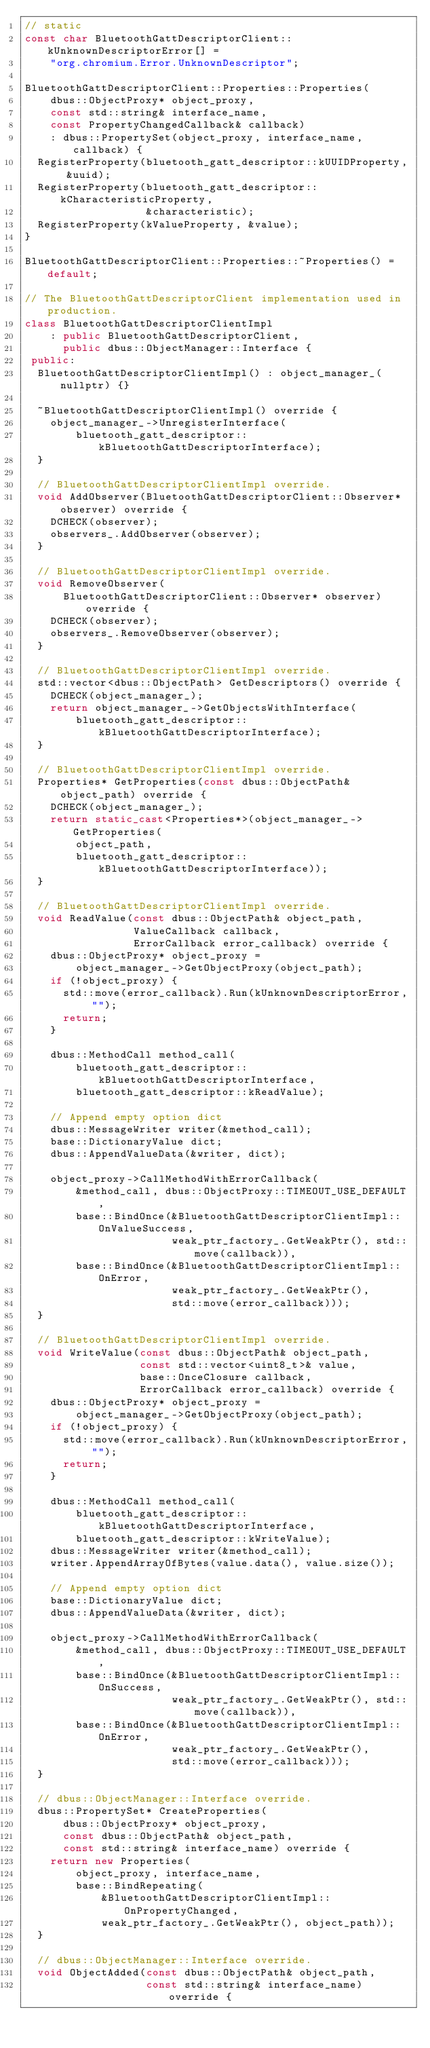<code> <loc_0><loc_0><loc_500><loc_500><_C++_>// static
const char BluetoothGattDescriptorClient::kUnknownDescriptorError[] =
    "org.chromium.Error.UnknownDescriptor";

BluetoothGattDescriptorClient::Properties::Properties(
    dbus::ObjectProxy* object_proxy,
    const std::string& interface_name,
    const PropertyChangedCallback& callback)
    : dbus::PropertySet(object_proxy, interface_name, callback) {
  RegisterProperty(bluetooth_gatt_descriptor::kUUIDProperty, &uuid);
  RegisterProperty(bluetooth_gatt_descriptor::kCharacteristicProperty,
                   &characteristic);
  RegisterProperty(kValueProperty, &value);
}

BluetoothGattDescriptorClient::Properties::~Properties() = default;

// The BluetoothGattDescriptorClient implementation used in production.
class BluetoothGattDescriptorClientImpl
    : public BluetoothGattDescriptorClient,
      public dbus::ObjectManager::Interface {
 public:
  BluetoothGattDescriptorClientImpl() : object_manager_(nullptr) {}

  ~BluetoothGattDescriptorClientImpl() override {
    object_manager_->UnregisterInterface(
        bluetooth_gatt_descriptor::kBluetoothGattDescriptorInterface);
  }

  // BluetoothGattDescriptorClientImpl override.
  void AddObserver(BluetoothGattDescriptorClient::Observer* observer) override {
    DCHECK(observer);
    observers_.AddObserver(observer);
  }

  // BluetoothGattDescriptorClientImpl override.
  void RemoveObserver(
      BluetoothGattDescriptorClient::Observer* observer) override {
    DCHECK(observer);
    observers_.RemoveObserver(observer);
  }

  // BluetoothGattDescriptorClientImpl override.
  std::vector<dbus::ObjectPath> GetDescriptors() override {
    DCHECK(object_manager_);
    return object_manager_->GetObjectsWithInterface(
        bluetooth_gatt_descriptor::kBluetoothGattDescriptorInterface);
  }

  // BluetoothGattDescriptorClientImpl override.
  Properties* GetProperties(const dbus::ObjectPath& object_path) override {
    DCHECK(object_manager_);
    return static_cast<Properties*>(object_manager_->GetProperties(
        object_path,
        bluetooth_gatt_descriptor::kBluetoothGattDescriptorInterface));
  }

  // BluetoothGattDescriptorClientImpl override.
  void ReadValue(const dbus::ObjectPath& object_path,
                 ValueCallback callback,
                 ErrorCallback error_callback) override {
    dbus::ObjectProxy* object_proxy =
        object_manager_->GetObjectProxy(object_path);
    if (!object_proxy) {
      std::move(error_callback).Run(kUnknownDescriptorError, "");
      return;
    }

    dbus::MethodCall method_call(
        bluetooth_gatt_descriptor::kBluetoothGattDescriptorInterface,
        bluetooth_gatt_descriptor::kReadValue);

    // Append empty option dict
    dbus::MessageWriter writer(&method_call);
    base::DictionaryValue dict;
    dbus::AppendValueData(&writer, dict);

    object_proxy->CallMethodWithErrorCallback(
        &method_call, dbus::ObjectProxy::TIMEOUT_USE_DEFAULT,
        base::BindOnce(&BluetoothGattDescriptorClientImpl::OnValueSuccess,
                       weak_ptr_factory_.GetWeakPtr(), std::move(callback)),
        base::BindOnce(&BluetoothGattDescriptorClientImpl::OnError,
                       weak_ptr_factory_.GetWeakPtr(),
                       std::move(error_callback)));
  }

  // BluetoothGattDescriptorClientImpl override.
  void WriteValue(const dbus::ObjectPath& object_path,
                  const std::vector<uint8_t>& value,
                  base::OnceClosure callback,
                  ErrorCallback error_callback) override {
    dbus::ObjectProxy* object_proxy =
        object_manager_->GetObjectProxy(object_path);
    if (!object_proxy) {
      std::move(error_callback).Run(kUnknownDescriptorError, "");
      return;
    }

    dbus::MethodCall method_call(
        bluetooth_gatt_descriptor::kBluetoothGattDescriptorInterface,
        bluetooth_gatt_descriptor::kWriteValue);
    dbus::MessageWriter writer(&method_call);
    writer.AppendArrayOfBytes(value.data(), value.size());

    // Append empty option dict
    base::DictionaryValue dict;
    dbus::AppendValueData(&writer, dict);

    object_proxy->CallMethodWithErrorCallback(
        &method_call, dbus::ObjectProxy::TIMEOUT_USE_DEFAULT,
        base::BindOnce(&BluetoothGattDescriptorClientImpl::OnSuccess,
                       weak_ptr_factory_.GetWeakPtr(), std::move(callback)),
        base::BindOnce(&BluetoothGattDescriptorClientImpl::OnError,
                       weak_ptr_factory_.GetWeakPtr(),
                       std::move(error_callback)));
  }

  // dbus::ObjectManager::Interface override.
  dbus::PropertySet* CreateProperties(
      dbus::ObjectProxy* object_proxy,
      const dbus::ObjectPath& object_path,
      const std::string& interface_name) override {
    return new Properties(
        object_proxy, interface_name,
        base::BindRepeating(
            &BluetoothGattDescriptorClientImpl::OnPropertyChanged,
            weak_ptr_factory_.GetWeakPtr(), object_path));
  }

  // dbus::ObjectManager::Interface override.
  void ObjectAdded(const dbus::ObjectPath& object_path,
                   const std::string& interface_name) override {</code> 